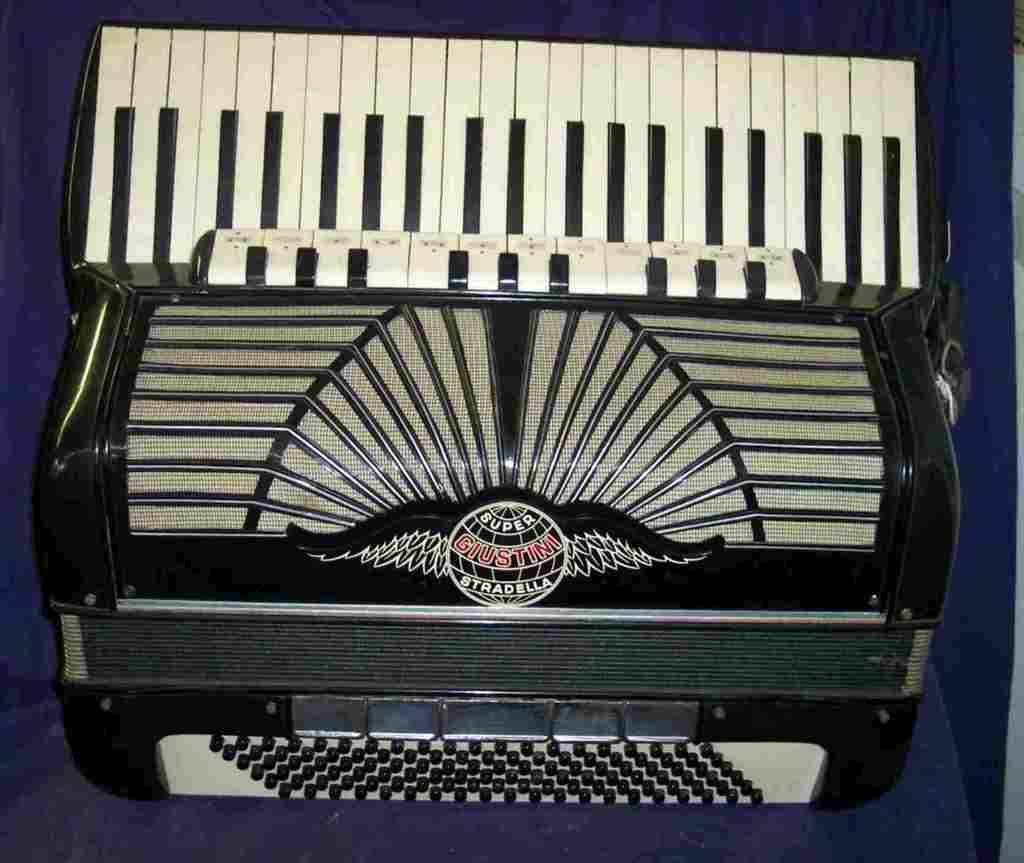Can you describe this image briefly? In this image, this looks like a musical instrument named as Hohner Atlantic. I can see a logo on the musical instrument. The background looks dark blue in color. 